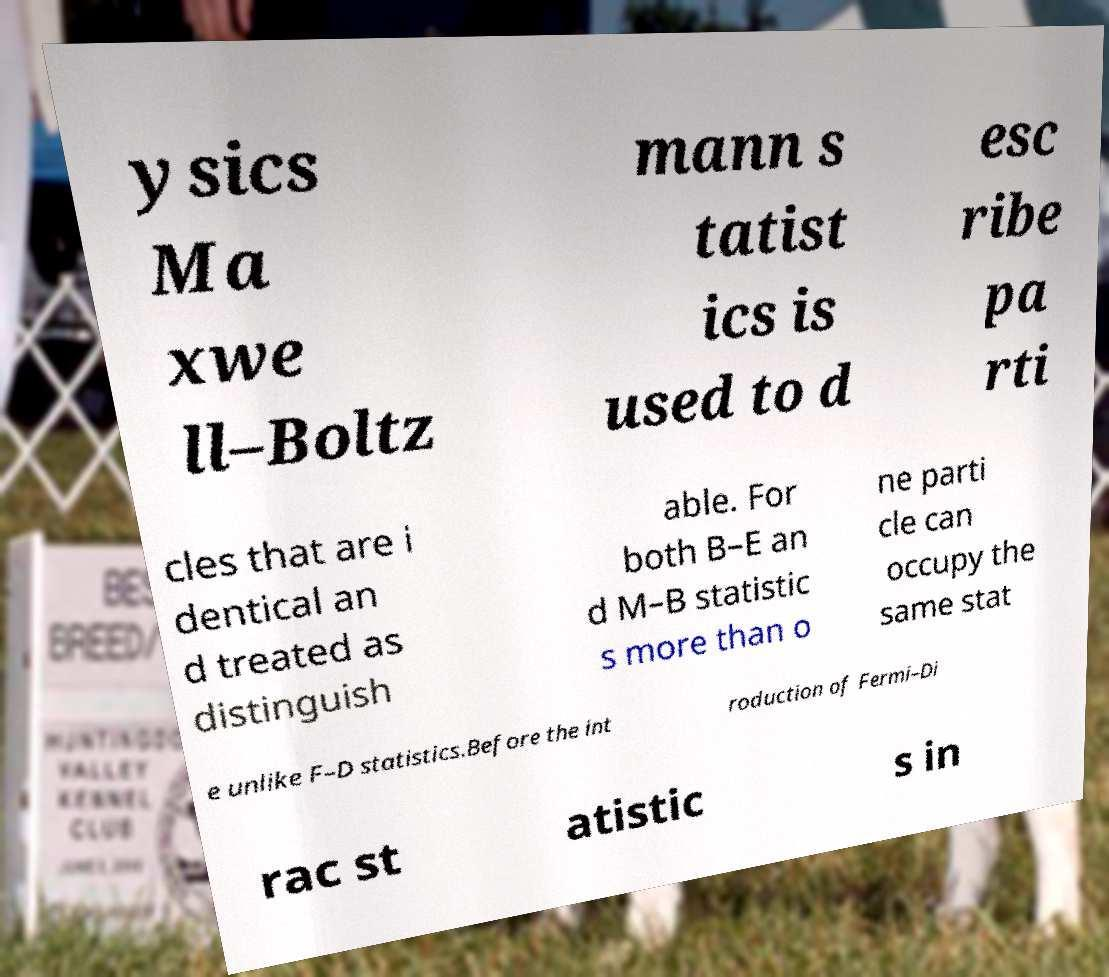I need the written content from this picture converted into text. Can you do that? ysics Ma xwe ll–Boltz mann s tatist ics is used to d esc ribe pa rti cles that are i dentical an d treated as distinguish able. For both B–E an d M–B statistic s more than o ne parti cle can occupy the same stat e unlike F–D statistics.Before the int roduction of Fermi–Di rac st atistic s in 